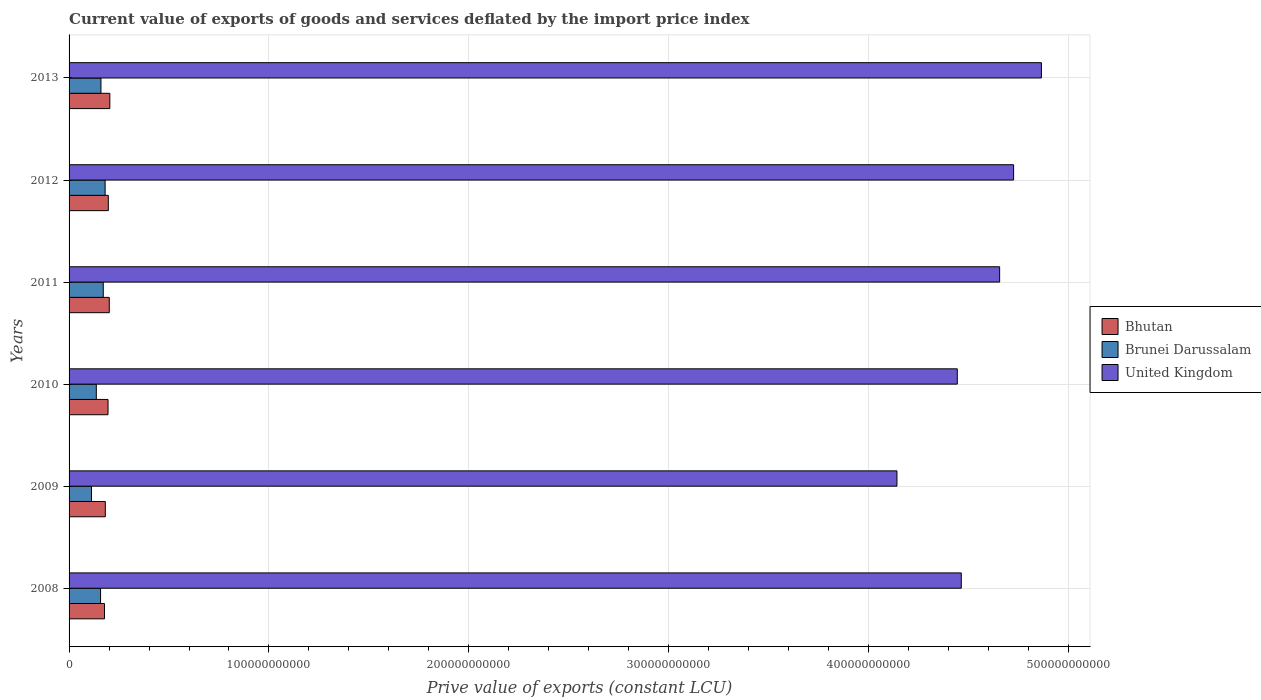Are the number of bars on each tick of the Y-axis equal?
Provide a succinct answer. Yes. How many bars are there on the 2nd tick from the top?
Offer a very short reply. 3. How many bars are there on the 6th tick from the bottom?
Keep it short and to the point. 3. In how many cases, is the number of bars for a given year not equal to the number of legend labels?
Ensure brevity in your answer.  0. What is the prive value of exports in Bhutan in 2011?
Provide a short and direct response. 2.01e+1. Across all years, what is the maximum prive value of exports in Brunei Darussalam?
Your response must be concise. 1.80e+1. Across all years, what is the minimum prive value of exports in Bhutan?
Offer a very short reply. 1.77e+1. What is the total prive value of exports in Brunei Darussalam in the graph?
Offer a very short reply. 9.17e+1. What is the difference between the prive value of exports in Bhutan in 2010 and that in 2011?
Provide a succinct answer. -6.25e+08. What is the difference between the prive value of exports in Brunei Darussalam in 2010 and the prive value of exports in Bhutan in 2009?
Your answer should be compact. -4.50e+09. What is the average prive value of exports in Brunei Darussalam per year?
Your response must be concise. 1.53e+1. In the year 2011, what is the difference between the prive value of exports in Bhutan and prive value of exports in United Kingdom?
Keep it short and to the point. -4.45e+11. In how many years, is the prive value of exports in Brunei Darussalam greater than 240000000000 LCU?
Provide a short and direct response. 0. What is the ratio of the prive value of exports in United Kingdom in 2012 to that in 2013?
Make the answer very short. 0.97. Is the prive value of exports in Bhutan in 2012 less than that in 2013?
Make the answer very short. Yes. What is the difference between the highest and the second highest prive value of exports in Brunei Darussalam?
Offer a very short reply. 9.31e+08. What is the difference between the highest and the lowest prive value of exports in United Kingdom?
Offer a terse response. 7.23e+1. In how many years, is the prive value of exports in United Kingdom greater than the average prive value of exports in United Kingdom taken over all years?
Make the answer very short. 3. Is the sum of the prive value of exports in Bhutan in 2009 and 2012 greater than the maximum prive value of exports in Brunei Darussalam across all years?
Give a very brief answer. Yes. What does the 3rd bar from the bottom in 2011 represents?
Offer a terse response. United Kingdom. How many bars are there?
Make the answer very short. 18. Are all the bars in the graph horizontal?
Your answer should be compact. Yes. What is the difference between two consecutive major ticks on the X-axis?
Provide a short and direct response. 1.00e+11. Does the graph contain any zero values?
Your answer should be compact. No. Does the graph contain grids?
Your response must be concise. Yes. How are the legend labels stacked?
Offer a very short reply. Vertical. What is the title of the graph?
Offer a very short reply. Current value of exports of goods and services deflated by the import price index. Does "High income: nonOECD" appear as one of the legend labels in the graph?
Provide a succinct answer. No. What is the label or title of the X-axis?
Give a very brief answer. Prive value of exports (constant LCU). What is the label or title of the Y-axis?
Provide a succinct answer. Years. What is the Prive value of exports (constant LCU) in Bhutan in 2008?
Provide a short and direct response. 1.77e+1. What is the Prive value of exports (constant LCU) of Brunei Darussalam in 2008?
Keep it short and to the point. 1.58e+1. What is the Prive value of exports (constant LCU) in United Kingdom in 2008?
Your answer should be very brief. 4.46e+11. What is the Prive value of exports (constant LCU) of Bhutan in 2009?
Keep it short and to the point. 1.81e+1. What is the Prive value of exports (constant LCU) of Brunei Darussalam in 2009?
Your response must be concise. 1.12e+1. What is the Prive value of exports (constant LCU) of United Kingdom in 2009?
Ensure brevity in your answer.  4.14e+11. What is the Prive value of exports (constant LCU) of Bhutan in 2010?
Offer a terse response. 1.95e+1. What is the Prive value of exports (constant LCU) of Brunei Darussalam in 2010?
Give a very brief answer. 1.36e+1. What is the Prive value of exports (constant LCU) in United Kingdom in 2010?
Your answer should be compact. 4.44e+11. What is the Prive value of exports (constant LCU) in Bhutan in 2011?
Ensure brevity in your answer.  2.01e+1. What is the Prive value of exports (constant LCU) in Brunei Darussalam in 2011?
Make the answer very short. 1.71e+1. What is the Prive value of exports (constant LCU) of United Kingdom in 2011?
Provide a short and direct response. 4.66e+11. What is the Prive value of exports (constant LCU) of Bhutan in 2012?
Your answer should be compact. 1.96e+1. What is the Prive value of exports (constant LCU) in Brunei Darussalam in 2012?
Provide a short and direct response. 1.80e+1. What is the Prive value of exports (constant LCU) of United Kingdom in 2012?
Give a very brief answer. 4.73e+11. What is the Prive value of exports (constant LCU) of Bhutan in 2013?
Your response must be concise. 2.04e+1. What is the Prive value of exports (constant LCU) in Brunei Darussalam in 2013?
Your answer should be very brief. 1.60e+1. What is the Prive value of exports (constant LCU) in United Kingdom in 2013?
Your response must be concise. 4.86e+11. Across all years, what is the maximum Prive value of exports (constant LCU) in Bhutan?
Provide a succinct answer. 2.04e+1. Across all years, what is the maximum Prive value of exports (constant LCU) in Brunei Darussalam?
Offer a very short reply. 1.80e+1. Across all years, what is the maximum Prive value of exports (constant LCU) of United Kingdom?
Ensure brevity in your answer.  4.86e+11. Across all years, what is the minimum Prive value of exports (constant LCU) of Bhutan?
Offer a terse response. 1.77e+1. Across all years, what is the minimum Prive value of exports (constant LCU) in Brunei Darussalam?
Offer a terse response. 1.12e+1. Across all years, what is the minimum Prive value of exports (constant LCU) in United Kingdom?
Provide a succinct answer. 4.14e+11. What is the total Prive value of exports (constant LCU) of Bhutan in the graph?
Your answer should be very brief. 1.15e+11. What is the total Prive value of exports (constant LCU) of Brunei Darussalam in the graph?
Ensure brevity in your answer.  9.17e+1. What is the total Prive value of exports (constant LCU) in United Kingdom in the graph?
Provide a short and direct response. 2.73e+12. What is the difference between the Prive value of exports (constant LCU) in Bhutan in 2008 and that in 2009?
Your response must be concise. -4.05e+08. What is the difference between the Prive value of exports (constant LCU) in Brunei Darussalam in 2008 and that in 2009?
Your response must be concise. 4.55e+09. What is the difference between the Prive value of exports (constant LCU) in United Kingdom in 2008 and that in 2009?
Your answer should be very brief. 3.22e+1. What is the difference between the Prive value of exports (constant LCU) in Bhutan in 2008 and that in 2010?
Ensure brevity in your answer.  -1.77e+09. What is the difference between the Prive value of exports (constant LCU) in Brunei Darussalam in 2008 and that in 2010?
Provide a succinct answer. 2.14e+09. What is the difference between the Prive value of exports (constant LCU) of United Kingdom in 2008 and that in 2010?
Make the answer very short. 2.00e+09. What is the difference between the Prive value of exports (constant LCU) of Bhutan in 2008 and that in 2011?
Your answer should be very brief. -2.39e+09. What is the difference between the Prive value of exports (constant LCU) in Brunei Darussalam in 2008 and that in 2011?
Your answer should be very brief. -1.34e+09. What is the difference between the Prive value of exports (constant LCU) of United Kingdom in 2008 and that in 2011?
Offer a very short reply. -1.92e+1. What is the difference between the Prive value of exports (constant LCU) in Bhutan in 2008 and that in 2012?
Ensure brevity in your answer.  -1.91e+09. What is the difference between the Prive value of exports (constant LCU) of Brunei Darussalam in 2008 and that in 2012?
Your answer should be compact. -2.27e+09. What is the difference between the Prive value of exports (constant LCU) in United Kingdom in 2008 and that in 2012?
Offer a terse response. -2.62e+1. What is the difference between the Prive value of exports (constant LCU) of Bhutan in 2008 and that in 2013?
Offer a terse response. -2.67e+09. What is the difference between the Prive value of exports (constant LCU) in Brunei Darussalam in 2008 and that in 2013?
Make the answer very short. -1.87e+08. What is the difference between the Prive value of exports (constant LCU) of United Kingdom in 2008 and that in 2013?
Ensure brevity in your answer.  -4.01e+1. What is the difference between the Prive value of exports (constant LCU) of Bhutan in 2009 and that in 2010?
Provide a short and direct response. -1.36e+09. What is the difference between the Prive value of exports (constant LCU) of Brunei Darussalam in 2009 and that in 2010?
Ensure brevity in your answer.  -2.41e+09. What is the difference between the Prive value of exports (constant LCU) of United Kingdom in 2009 and that in 2010?
Keep it short and to the point. -3.02e+1. What is the difference between the Prive value of exports (constant LCU) of Bhutan in 2009 and that in 2011?
Provide a short and direct response. -1.99e+09. What is the difference between the Prive value of exports (constant LCU) in Brunei Darussalam in 2009 and that in 2011?
Keep it short and to the point. -5.89e+09. What is the difference between the Prive value of exports (constant LCU) in United Kingdom in 2009 and that in 2011?
Offer a terse response. -5.14e+1. What is the difference between the Prive value of exports (constant LCU) in Bhutan in 2009 and that in 2012?
Provide a short and direct response. -1.50e+09. What is the difference between the Prive value of exports (constant LCU) in Brunei Darussalam in 2009 and that in 2012?
Provide a short and direct response. -6.82e+09. What is the difference between the Prive value of exports (constant LCU) in United Kingdom in 2009 and that in 2012?
Offer a terse response. -5.84e+1. What is the difference between the Prive value of exports (constant LCU) in Bhutan in 2009 and that in 2013?
Offer a terse response. -2.26e+09. What is the difference between the Prive value of exports (constant LCU) in Brunei Darussalam in 2009 and that in 2013?
Offer a very short reply. -4.74e+09. What is the difference between the Prive value of exports (constant LCU) of United Kingdom in 2009 and that in 2013?
Provide a short and direct response. -7.23e+1. What is the difference between the Prive value of exports (constant LCU) in Bhutan in 2010 and that in 2011?
Offer a very short reply. -6.25e+08. What is the difference between the Prive value of exports (constant LCU) in Brunei Darussalam in 2010 and that in 2011?
Offer a terse response. -3.48e+09. What is the difference between the Prive value of exports (constant LCU) of United Kingdom in 2010 and that in 2011?
Keep it short and to the point. -2.12e+1. What is the difference between the Prive value of exports (constant LCU) in Bhutan in 2010 and that in 2012?
Your answer should be compact. -1.41e+08. What is the difference between the Prive value of exports (constant LCU) of Brunei Darussalam in 2010 and that in 2012?
Offer a terse response. -4.41e+09. What is the difference between the Prive value of exports (constant LCU) in United Kingdom in 2010 and that in 2012?
Provide a short and direct response. -2.82e+1. What is the difference between the Prive value of exports (constant LCU) of Bhutan in 2010 and that in 2013?
Your answer should be very brief. -9.02e+08. What is the difference between the Prive value of exports (constant LCU) of Brunei Darussalam in 2010 and that in 2013?
Provide a succinct answer. -2.33e+09. What is the difference between the Prive value of exports (constant LCU) of United Kingdom in 2010 and that in 2013?
Make the answer very short. -4.21e+1. What is the difference between the Prive value of exports (constant LCU) of Bhutan in 2011 and that in 2012?
Ensure brevity in your answer.  4.83e+08. What is the difference between the Prive value of exports (constant LCU) in Brunei Darussalam in 2011 and that in 2012?
Your answer should be very brief. -9.31e+08. What is the difference between the Prive value of exports (constant LCU) in United Kingdom in 2011 and that in 2012?
Your answer should be compact. -6.99e+09. What is the difference between the Prive value of exports (constant LCU) of Bhutan in 2011 and that in 2013?
Make the answer very short. -2.77e+08. What is the difference between the Prive value of exports (constant LCU) in Brunei Darussalam in 2011 and that in 2013?
Your answer should be compact. 1.15e+09. What is the difference between the Prive value of exports (constant LCU) of United Kingdom in 2011 and that in 2013?
Ensure brevity in your answer.  -2.09e+1. What is the difference between the Prive value of exports (constant LCU) of Bhutan in 2012 and that in 2013?
Provide a short and direct response. -7.60e+08. What is the difference between the Prive value of exports (constant LCU) in Brunei Darussalam in 2012 and that in 2013?
Give a very brief answer. 2.08e+09. What is the difference between the Prive value of exports (constant LCU) in United Kingdom in 2012 and that in 2013?
Keep it short and to the point. -1.39e+1. What is the difference between the Prive value of exports (constant LCU) of Bhutan in 2008 and the Prive value of exports (constant LCU) of Brunei Darussalam in 2009?
Give a very brief answer. 6.51e+09. What is the difference between the Prive value of exports (constant LCU) in Bhutan in 2008 and the Prive value of exports (constant LCU) in United Kingdom in 2009?
Your answer should be compact. -3.96e+11. What is the difference between the Prive value of exports (constant LCU) in Brunei Darussalam in 2008 and the Prive value of exports (constant LCU) in United Kingdom in 2009?
Make the answer very short. -3.98e+11. What is the difference between the Prive value of exports (constant LCU) in Bhutan in 2008 and the Prive value of exports (constant LCU) in Brunei Darussalam in 2010?
Your response must be concise. 4.10e+09. What is the difference between the Prive value of exports (constant LCU) of Bhutan in 2008 and the Prive value of exports (constant LCU) of United Kingdom in 2010?
Provide a short and direct response. -4.27e+11. What is the difference between the Prive value of exports (constant LCU) in Brunei Darussalam in 2008 and the Prive value of exports (constant LCU) in United Kingdom in 2010?
Provide a short and direct response. -4.29e+11. What is the difference between the Prive value of exports (constant LCU) of Bhutan in 2008 and the Prive value of exports (constant LCU) of Brunei Darussalam in 2011?
Make the answer very short. 6.20e+08. What is the difference between the Prive value of exports (constant LCU) in Bhutan in 2008 and the Prive value of exports (constant LCU) in United Kingdom in 2011?
Your response must be concise. -4.48e+11. What is the difference between the Prive value of exports (constant LCU) in Brunei Darussalam in 2008 and the Prive value of exports (constant LCU) in United Kingdom in 2011?
Make the answer very short. -4.50e+11. What is the difference between the Prive value of exports (constant LCU) of Bhutan in 2008 and the Prive value of exports (constant LCU) of Brunei Darussalam in 2012?
Your answer should be very brief. -3.12e+08. What is the difference between the Prive value of exports (constant LCU) of Bhutan in 2008 and the Prive value of exports (constant LCU) of United Kingdom in 2012?
Your response must be concise. -4.55e+11. What is the difference between the Prive value of exports (constant LCU) of Brunei Darussalam in 2008 and the Prive value of exports (constant LCU) of United Kingdom in 2012?
Your answer should be compact. -4.57e+11. What is the difference between the Prive value of exports (constant LCU) in Bhutan in 2008 and the Prive value of exports (constant LCU) in Brunei Darussalam in 2013?
Your answer should be compact. 1.77e+09. What is the difference between the Prive value of exports (constant LCU) of Bhutan in 2008 and the Prive value of exports (constant LCU) of United Kingdom in 2013?
Offer a terse response. -4.69e+11. What is the difference between the Prive value of exports (constant LCU) of Brunei Darussalam in 2008 and the Prive value of exports (constant LCU) of United Kingdom in 2013?
Provide a succinct answer. -4.71e+11. What is the difference between the Prive value of exports (constant LCU) of Bhutan in 2009 and the Prive value of exports (constant LCU) of Brunei Darussalam in 2010?
Ensure brevity in your answer.  4.50e+09. What is the difference between the Prive value of exports (constant LCU) of Bhutan in 2009 and the Prive value of exports (constant LCU) of United Kingdom in 2010?
Keep it short and to the point. -4.26e+11. What is the difference between the Prive value of exports (constant LCU) of Brunei Darussalam in 2009 and the Prive value of exports (constant LCU) of United Kingdom in 2010?
Keep it short and to the point. -4.33e+11. What is the difference between the Prive value of exports (constant LCU) in Bhutan in 2009 and the Prive value of exports (constant LCU) in Brunei Darussalam in 2011?
Offer a very short reply. 1.02e+09. What is the difference between the Prive value of exports (constant LCU) in Bhutan in 2009 and the Prive value of exports (constant LCU) in United Kingdom in 2011?
Your answer should be compact. -4.47e+11. What is the difference between the Prive value of exports (constant LCU) in Brunei Darussalam in 2009 and the Prive value of exports (constant LCU) in United Kingdom in 2011?
Give a very brief answer. -4.54e+11. What is the difference between the Prive value of exports (constant LCU) of Bhutan in 2009 and the Prive value of exports (constant LCU) of Brunei Darussalam in 2012?
Make the answer very short. 9.37e+07. What is the difference between the Prive value of exports (constant LCU) of Bhutan in 2009 and the Prive value of exports (constant LCU) of United Kingdom in 2012?
Provide a succinct answer. -4.54e+11. What is the difference between the Prive value of exports (constant LCU) in Brunei Darussalam in 2009 and the Prive value of exports (constant LCU) in United Kingdom in 2012?
Your answer should be very brief. -4.61e+11. What is the difference between the Prive value of exports (constant LCU) in Bhutan in 2009 and the Prive value of exports (constant LCU) in Brunei Darussalam in 2013?
Your response must be concise. 2.18e+09. What is the difference between the Prive value of exports (constant LCU) of Bhutan in 2009 and the Prive value of exports (constant LCU) of United Kingdom in 2013?
Offer a terse response. -4.68e+11. What is the difference between the Prive value of exports (constant LCU) in Brunei Darussalam in 2009 and the Prive value of exports (constant LCU) in United Kingdom in 2013?
Your response must be concise. -4.75e+11. What is the difference between the Prive value of exports (constant LCU) of Bhutan in 2010 and the Prive value of exports (constant LCU) of Brunei Darussalam in 2011?
Keep it short and to the point. 2.39e+09. What is the difference between the Prive value of exports (constant LCU) in Bhutan in 2010 and the Prive value of exports (constant LCU) in United Kingdom in 2011?
Your answer should be very brief. -4.46e+11. What is the difference between the Prive value of exports (constant LCU) in Brunei Darussalam in 2010 and the Prive value of exports (constant LCU) in United Kingdom in 2011?
Offer a very short reply. -4.52e+11. What is the difference between the Prive value of exports (constant LCU) in Bhutan in 2010 and the Prive value of exports (constant LCU) in Brunei Darussalam in 2012?
Offer a very short reply. 1.46e+09. What is the difference between the Prive value of exports (constant LCU) in Bhutan in 2010 and the Prive value of exports (constant LCU) in United Kingdom in 2012?
Your answer should be very brief. -4.53e+11. What is the difference between the Prive value of exports (constant LCU) in Brunei Darussalam in 2010 and the Prive value of exports (constant LCU) in United Kingdom in 2012?
Give a very brief answer. -4.59e+11. What is the difference between the Prive value of exports (constant LCU) in Bhutan in 2010 and the Prive value of exports (constant LCU) in Brunei Darussalam in 2013?
Provide a short and direct response. 3.54e+09. What is the difference between the Prive value of exports (constant LCU) of Bhutan in 2010 and the Prive value of exports (constant LCU) of United Kingdom in 2013?
Your answer should be very brief. -4.67e+11. What is the difference between the Prive value of exports (constant LCU) in Brunei Darussalam in 2010 and the Prive value of exports (constant LCU) in United Kingdom in 2013?
Your answer should be very brief. -4.73e+11. What is the difference between the Prive value of exports (constant LCU) of Bhutan in 2011 and the Prive value of exports (constant LCU) of Brunei Darussalam in 2012?
Offer a very short reply. 2.08e+09. What is the difference between the Prive value of exports (constant LCU) in Bhutan in 2011 and the Prive value of exports (constant LCU) in United Kingdom in 2012?
Give a very brief answer. -4.52e+11. What is the difference between the Prive value of exports (constant LCU) of Brunei Darussalam in 2011 and the Prive value of exports (constant LCU) of United Kingdom in 2012?
Give a very brief answer. -4.55e+11. What is the difference between the Prive value of exports (constant LCU) in Bhutan in 2011 and the Prive value of exports (constant LCU) in Brunei Darussalam in 2013?
Provide a succinct answer. 4.16e+09. What is the difference between the Prive value of exports (constant LCU) in Bhutan in 2011 and the Prive value of exports (constant LCU) in United Kingdom in 2013?
Your response must be concise. -4.66e+11. What is the difference between the Prive value of exports (constant LCU) in Brunei Darussalam in 2011 and the Prive value of exports (constant LCU) in United Kingdom in 2013?
Provide a succinct answer. -4.69e+11. What is the difference between the Prive value of exports (constant LCU) in Bhutan in 2012 and the Prive value of exports (constant LCU) in Brunei Darussalam in 2013?
Keep it short and to the point. 3.68e+09. What is the difference between the Prive value of exports (constant LCU) in Bhutan in 2012 and the Prive value of exports (constant LCU) in United Kingdom in 2013?
Make the answer very short. -4.67e+11. What is the difference between the Prive value of exports (constant LCU) of Brunei Darussalam in 2012 and the Prive value of exports (constant LCU) of United Kingdom in 2013?
Provide a succinct answer. -4.68e+11. What is the average Prive value of exports (constant LCU) in Bhutan per year?
Provide a succinct answer. 1.92e+1. What is the average Prive value of exports (constant LCU) in Brunei Darussalam per year?
Your answer should be very brief. 1.53e+1. What is the average Prive value of exports (constant LCU) of United Kingdom per year?
Keep it short and to the point. 4.55e+11. In the year 2008, what is the difference between the Prive value of exports (constant LCU) in Bhutan and Prive value of exports (constant LCU) in Brunei Darussalam?
Give a very brief answer. 1.96e+09. In the year 2008, what is the difference between the Prive value of exports (constant LCU) of Bhutan and Prive value of exports (constant LCU) of United Kingdom?
Keep it short and to the point. -4.29e+11. In the year 2008, what is the difference between the Prive value of exports (constant LCU) in Brunei Darussalam and Prive value of exports (constant LCU) in United Kingdom?
Make the answer very short. -4.31e+11. In the year 2009, what is the difference between the Prive value of exports (constant LCU) of Bhutan and Prive value of exports (constant LCU) of Brunei Darussalam?
Offer a terse response. 6.91e+09. In the year 2009, what is the difference between the Prive value of exports (constant LCU) in Bhutan and Prive value of exports (constant LCU) in United Kingdom?
Offer a very short reply. -3.96e+11. In the year 2009, what is the difference between the Prive value of exports (constant LCU) in Brunei Darussalam and Prive value of exports (constant LCU) in United Kingdom?
Your answer should be very brief. -4.03e+11. In the year 2010, what is the difference between the Prive value of exports (constant LCU) in Bhutan and Prive value of exports (constant LCU) in Brunei Darussalam?
Keep it short and to the point. 5.86e+09. In the year 2010, what is the difference between the Prive value of exports (constant LCU) in Bhutan and Prive value of exports (constant LCU) in United Kingdom?
Provide a short and direct response. -4.25e+11. In the year 2010, what is the difference between the Prive value of exports (constant LCU) of Brunei Darussalam and Prive value of exports (constant LCU) of United Kingdom?
Make the answer very short. -4.31e+11. In the year 2011, what is the difference between the Prive value of exports (constant LCU) of Bhutan and Prive value of exports (constant LCU) of Brunei Darussalam?
Offer a very short reply. 3.01e+09. In the year 2011, what is the difference between the Prive value of exports (constant LCU) in Bhutan and Prive value of exports (constant LCU) in United Kingdom?
Make the answer very short. -4.45e+11. In the year 2011, what is the difference between the Prive value of exports (constant LCU) of Brunei Darussalam and Prive value of exports (constant LCU) of United Kingdom?
Give a very brief answer. -4.48e+11. In the year 2012, what is the difference between the Prive value of exports (constant LCU) in Bhutan and Prive value of exports (constant LCU) in Brunei Darussalam?
Ensure brevity in your answer.  1.60e+09. In the year 2012, what is the difference between the Prive value of exports (constant LCU) of Bhutan and Prive value of exports (constant LCU) of United Kingdom?
Your answer should be compact. -4.53e+11. In the year 2012, what is the difference between the Prive value of exports (constant LCU) in Brunei Darussalam and Prive value of exports (constant LCU) in United Kingdom?
Your answer should be very brief. -4.55e+11. In the year 2013, what is the difference between the Prive value of exports (constant LCU) of Bhutan and Prive value of exports (constant LCU) of Brunei Darussalam?
Provide a succinct answer. 4.44e+09. In the year 2013, what is the difference between the Prive value of exports (constant LCU) in Bhutan and Prive value of exports (constant LCU) in United Kingdom?
Offer a terse response. -4.66e+11. In the year 2013, what is the difference between the Prive value of exports (constant LCU) of Brunei Darussalam and Prive value of exports (constant LCU) of United Kingdom?
Give a very brief answer. -4.71e+11. What is the ratio of the Prive value of exports (constant LCU) in Bhutan in 2008 to that in 2009?
Your response must be concise. 0.98. What is the ratio of the Prive value of exports (constant LCU) of Brunei Darussalam in 2008 to that in 2009?
Offer a terse response. 1.41. What is the ratio of the Prive value of exports (constant LCU) of United Kingdom in 2008 to that in 2009?
Give a very brief answer. 1.08. What is the ratio of the Prive value of exports (constant LCU) in Bhutan in 2008 to that in 2010?
Give a very brief answer. 0.91. What is the ratio of the Prive value of exports (constant LCU) in Brunei Darussalam in 2008 to that in 2010?
Your answer should be very brief. 1.16. What is the ratio of the Prive value of exports (constant LCU) of Bhutan in 2008 to that in 2011?
Offer a terse response. 0.88. What is the ratio of the Prive value of exports (constant LCU) of Brunei Darussalam in 2008 to that in 2011?
Your response must be concise. 0.92. What is the ratio of the Prive value of exports (constant LCU) of United Kingdom in 2008 to that in 2011?
Provide a short and direct response. 0.96. What is the ratio of the Prive value of exports (constant LCU) of Bhutan in 2008 to that in 2012?
Your answer should be very brief. 0.9. What is the ratio of the Prive value of exports (constant LCU) of Brunei Darussalam in 2008 to that in 2012?
Ensure brevity in your answer.  0.87. What is the ratio of the Prive value of exports (constant LCU) in United Kingdom in 2008 to that in 2012?
Ensure brevity in your answer.  0.94. What is the ratio of the Prive value of exports (constant LCU) of Bhutan in 2008 to that in 2013?
Make the answer very short. 0.87. What is the ratio of the Prive value of exports (constant LCU) in Brunei Darussalam in 2008 to that in 2013?
Your answer should be very brief. 0.99. What is the ratio of the Prive value of exports (constant LCU) of United Kingdom in 2008 to that in 2013?
Make the answer very short. 0.92. What is the ratio of the Prive value of exports (constant LCU) in Bhutan in 2009 to that in 2010?
Provide a short and direct response. 0.93. What is the ratio of the Prive value of exports (constant LCU) in Brunei Darussalam in 2009 to that in 2010?
Provide a short and direct response. 0.82. What is the ratio of the Prive value of exports (constant LCU) of United Kingdom in 2009 to that in 2010?
Offer a very short reply. 0.93. What is the ratio of the Prive value of exports (constant LCU) of Bhutan in 2009 to that in 2011?
Ensure brevity in your answer.  0.9. What is the ratio of the Prive value of exports (constant LCU) in Brunei Darussalam in 2009 to that in 2011?
Offer a terse response. 0.66. What is the ratio of the Prive value of exports (constant LCU) of United Kingdom in 2009 to that in 2011?
Offer a terse response. 0.89. What is the ratio of the Prive value of exports (constant LCU) of Bhutan in 2009 to that in 2012?
Offer a terse response. 0.92. What is the ratio of the Prive value of exports (constant LCU) of Brunei Darussalam in 2009 to that in 2012?
Ensure brevity in your answer.  0.62. What is the ratio of the Prive value of exports (constant LCU) of United Kingdom in 2009 to that in 2012?
Your answer should be compact. 0.88. What is the ratio of the Prive value of exports (constant LCU) of Bhutan in 2009 to that in 2013?
Offer a terse response. 0.89. What is the ratio of the Prive value of exports (constant LCU) in Brunei Darussalam in 2009 to that in 2013?
Your answer should be compact. 0.7. What is the ratio of the Prive value of exports (constant LCU) in United Kingdom in 2009 to that in 2013?
Your answer should be compact. 0.85. What is the ratio of the Prive value of exports (constant LCU) in Bhutan in 2010 to that in 2011?
Offer a very short reply. 0.97. What is the ratio of the Prive value of exports (constant LCU) of Brunei Darussalam in 2010 to that in 2011?
Give a very brief answer. 0.8. What is the ratio of the Prive value of exports (constant LCU) in United Kingdom in 2010 to that in 2011?
Provide a short and direct response. 0.95. What is the ratio of the Prive value of exports (constant LCU) of Brunei Darussalam in 2010 to that in 2012?
Provide a short and direct response. 0.76. What is the ratio of the Prive value of exports (constant LCU) in United Kingdom in 2010 to that in 2012?
Your answer should be compact. 0.94. What is the ratio of the Prive value of exports (constant LCU) of Bhutan in 2010 to that in 2013?
Your answer should be compact. 0.96. What is the ratio of the Prive value of exports (constant LCU) of Brunei Darussalam in 2010 to that in 2013?
Offer a terse response. 0.85. What is the ratio of the Prive value of exports (constant LCU) of United Kingdom in 2010 to that in 2013?
Provide a succinct answer. 0.91. What is the ratio of the Prive value of exports (constant LCU) of Bhutan in 2011 to that in 2012?
Provide a succinct answer. 1.02. What is the ratio of the Prive value of exports (constant LCU) in Brunei Darussalam in 2011 to that in 2012?
Offer a very short reply. 0.95. What is the ratio of the Prive value of exports (constant LCU) of United Kingdom in 2011 to that in 2012?
Keep it short and to the point. 0.99. What is the ratio of the Prive value of exports (constant LCU) in Bhutan in 2011 to that in 2013?
Provide a short and direct response. 0.99. What is the ratio of the Prive value of exports (constant LCU) in Brunei Darussalam in 2011 to that in 2013?
Ensure brevity in your answer.  1.07. What is the ratio of the Prive value of exports (constant LCU) of United Kingdom in 2011 to that in 2013?
Ensure brevity in your answer.  0.96. What is the ratio of the Prive value of exports (constant LCU) of Bhutan in 2012 to that in 2013?
Provide a short and direct response. 0.96. What is the ratio of the Prive value of exports (constant LCU) in Brunei Darussalam in 2012 to that in 2013?
Make the answer very short. 1.13. What is the ratio of the Prive value of exports (constant LCU) of United Kingdom in 2012 to that in 2013?
Give a very brief answer. 0.97. What is the difference between the highest and the second highest Prive value of exports (constant LCU) in Bhutan?
Provide a succinct answer. 2.77e+08. What is the difference between the highest and the second highest Prive value of exports (constant LCU) in Brunei Darussalam?
Your answer should be compact. 9.31e+08. What is the difference between the highest and the second highest Prive value of exports (constant LCU) in United Kingdom?
Keep it short and to the point. 1.39e+1. What is the difference between the highest and the lowest Prive value of exports (constant LCU) in Bhutan?
Your response must be concise. 2.67e+09. What is the difference between the highest and the lowest Prive value of exports (constant LCU) in Brunei Darussalam?
Offer a terse response. 6.82e+09. What is the difference between the highest and the lowest Prive value of exports (constant LCU) of United Kingdom?
Make the answer very short. 7.23e+1. 